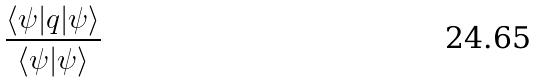Convert formula to latex. <formula><loc_0><loc_0><loc_500><loc_500>\frac { \langle \psi | q | \psi \rangle } { \langle \psi | \psi \rangle }</formula> 